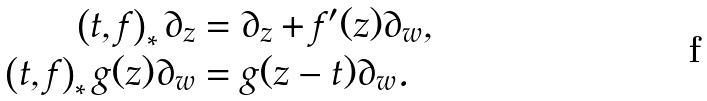Convert formula to latex. <formula><loc_0><loc_0><loc_500><loc_500>\left ( t , f \right ) _ { * } \partial _ { z } & = \partial _ { z } + f ^ { \prime } ( z ) \partial _ { w } , \\ \left ( t , f \right ) _ { * } g ( z ) \partial _ { w } & = g ( z - t ) \partial _ { w } .</formula> 